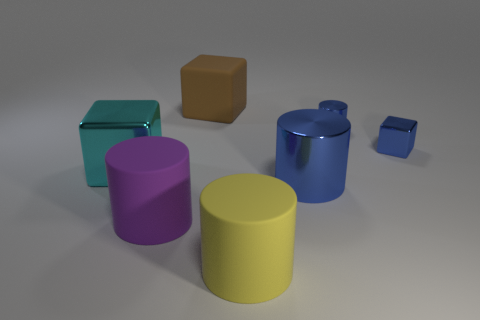Subtract 1 blocks. How many blocks are left? 2 Subtract all yellow blocks. Subtract all cyan spheres. How many blocks are left? 3 Add 1 brown matte blocks. How many objects exist? 8 Subtract all blocks. How many objects are left? 4 Add 2 big blue things. How many big blue things exist? 3 Subtract 0 blue balls. How many objects are left? 7 Subtract all yellow rubber cylinders. Subtract all brown matte blocks. How many objects are left? 5 Add 1 large purple matte objects. How many large purple matte objects are left? 2 